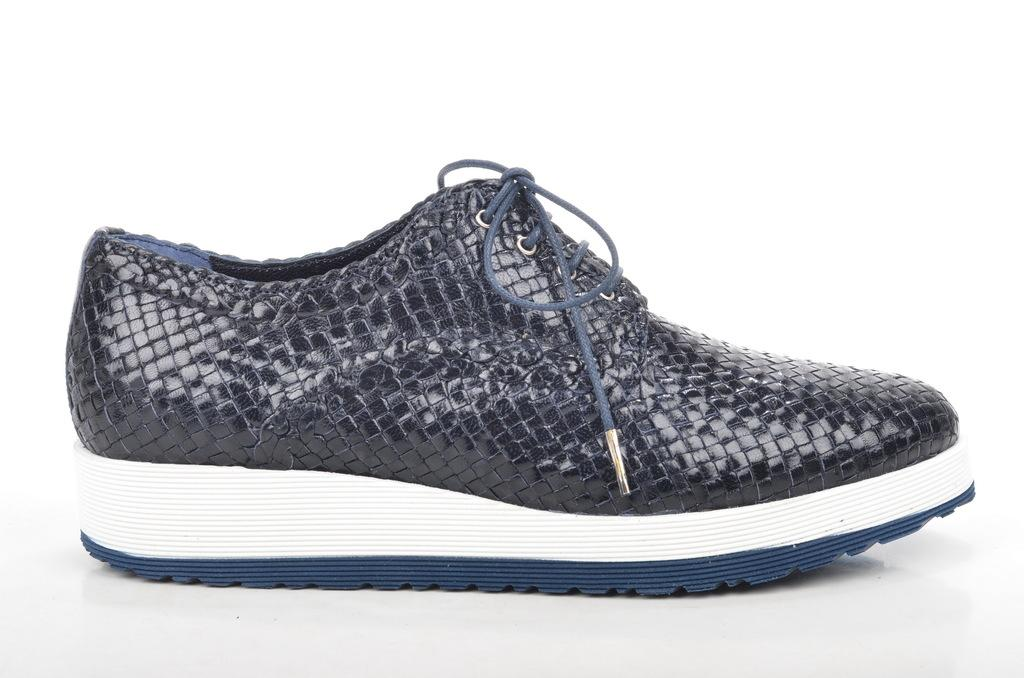What is the main subject of the image? The main subject of the image is a shoe. Can you describe the shoe's appearance? The shoe is blue and white in color, and it has a navy blue shoelace. Is the shoelace tied on the shoe? Yes, the shoelace is tied on the shoe. How does the crowd react to the impulse of the sand in the image? There is no crowd, impulse, or sand present in the image; it only features a shoe. 